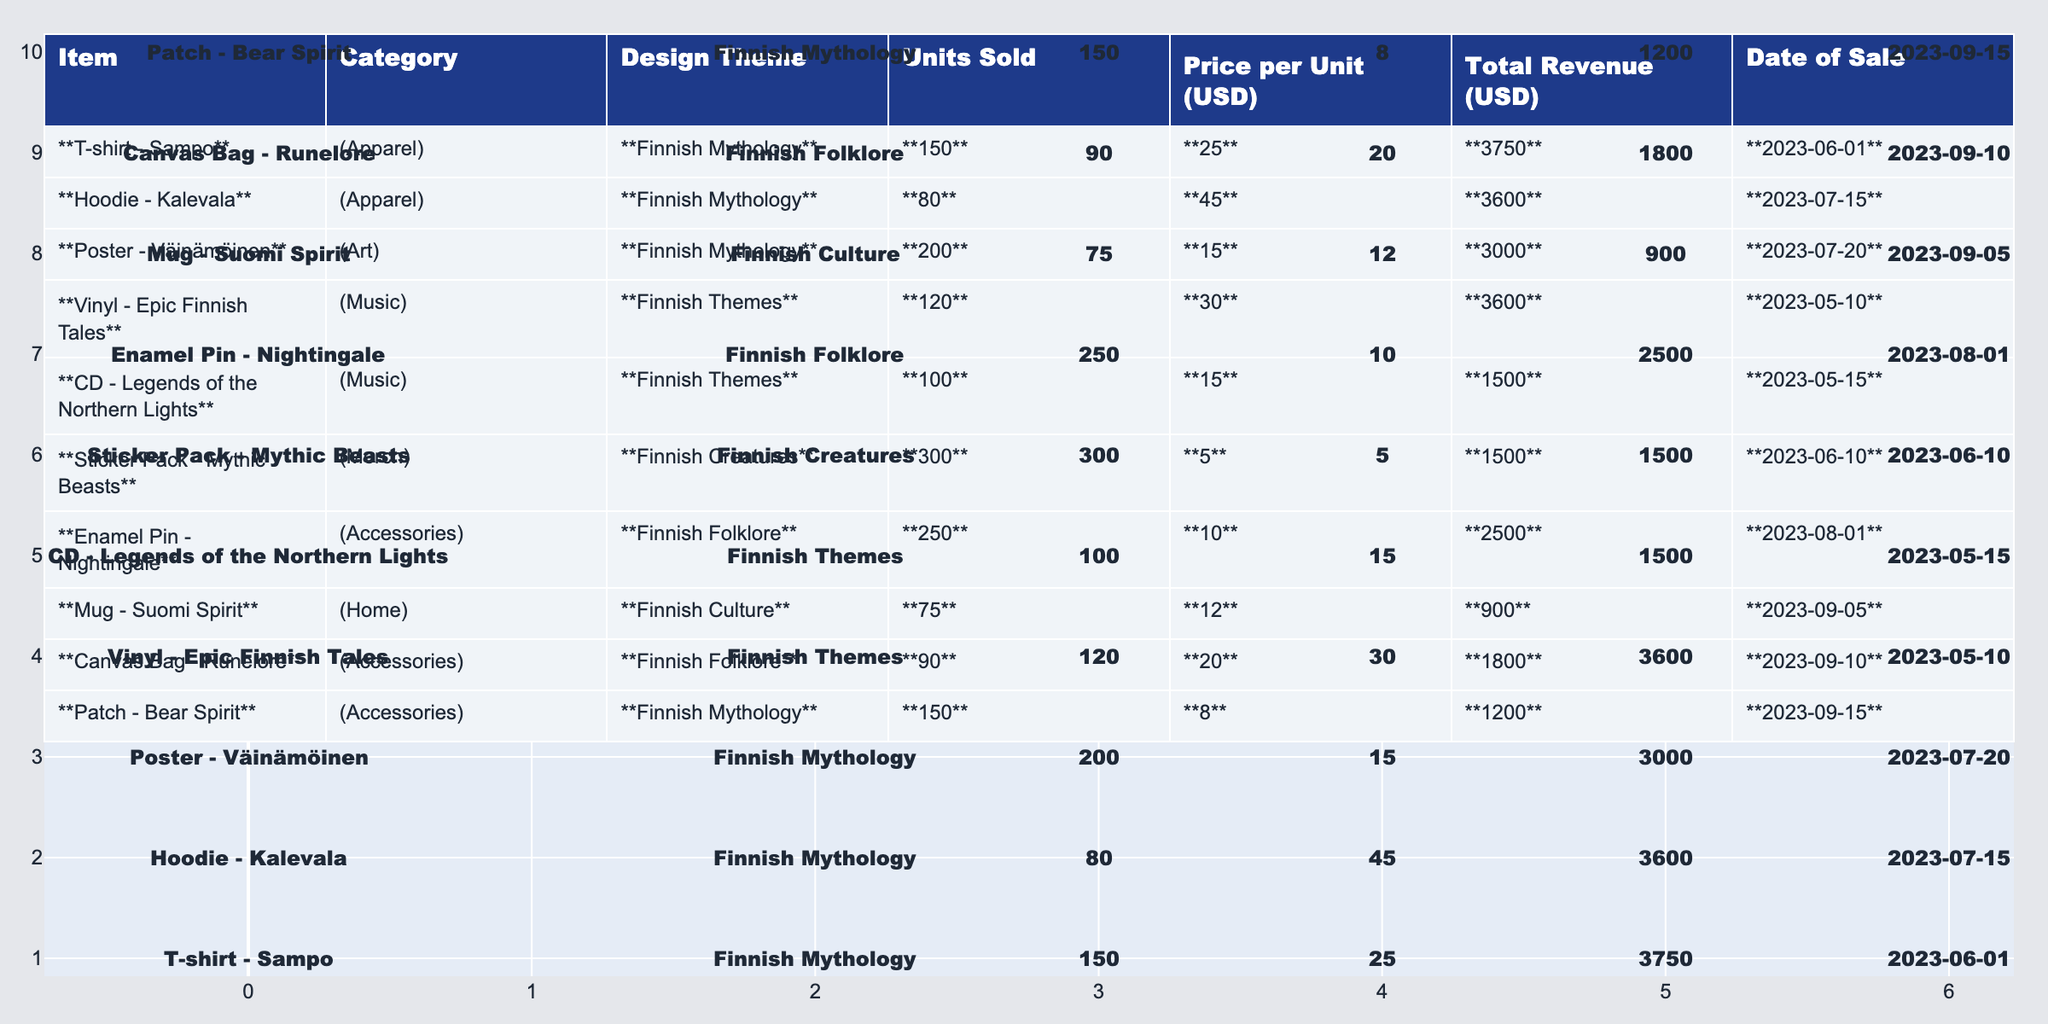What item sold the most units? The item with the highest "Units Sold" is the "Sticker Pack - Mythic Beasts," which sold **300** units.
Answer: Sticker Pack - Mythic Beasts What is the total revenue from the vinyl sales? The "Vinyl - Epic Finnish Tales" sold **120** units at a price of **$30** each, leading to total revenue of **120 x 30 = 3600** dollars.
Answer: 3600 Which apparel item generated more revenue, the T-shirt or the Hoodie? The T-shirt generated **3750** dollars, while the Hoodie generated **3600** dollars, so the T-shirt has higher revenue.
Answer: T-shirt How many total units of merchandise were sold? Summing up all units sold: 150 (T-shirt) + 80 (Hoodie) + 200 (Poster) + 120 (Vinyl) + 100 (CD) + 300 (Sticker Pack) + 250 (Pin) + 75 (Mug) + 90 (Bag) + 150 (Patch) = **1115** total units.
Answer: 1115 What percentage of total revenue comes from the Poster sales? The total revenue from all items is **$3750 + 3600 + 3000 + 3600 + 1500 + 1500 + 2500 + 900 + 1800 + 1200 = 19150**. The revenue from the Poster is **3000**. The percentage is (3000 / 19150) * 100 ≈ **15.65%**.
Answer: 15.65% Did the band sell more music-related items or apparel items? The sales for music items (Vinyl, CD) total **120 + 100 = 220** units and for apparel (T-shirt, Hoodie) total **150 + 80 = 230** units; hence, apparel items sold more.
Answer: Apparel items What was the average price of accessories sold? The accessories are the Enamel Pin, Canvas Bag, and Patch, costing **$10, $20,** and **$8** respectively. The average price is (10 + 20 + 8) / 3 = **$12.67**.
Answer: $12.67 Which item was sold last and how many units were sold? The last sale was the "Patch - Bear Spirit" on **2023-09-15**, which sold **150** units.
Answer: 150 